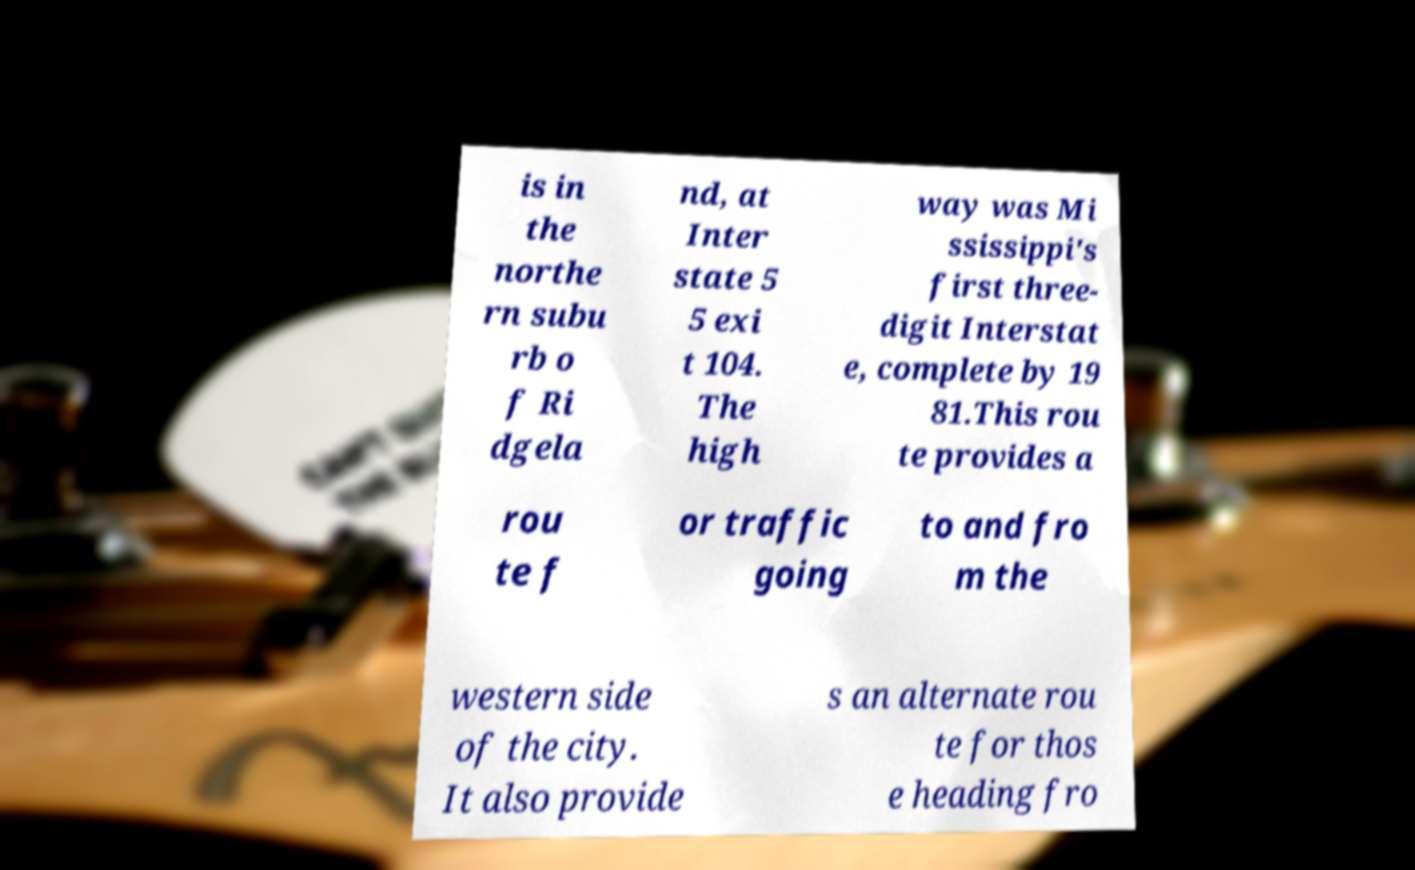Please identify and transcribe the text found in this image. is in the northe rn subu rb o f Ri dgela nd, at Inter state 5 5 exi t 104. The high way was Mi ssissippi's first three- digit Interstat e, complete by 19 81.This rou te provides a rou te f or traffic going to and fro m the western side of the city. It also provide s an alternate rou te for thos e heading fro 